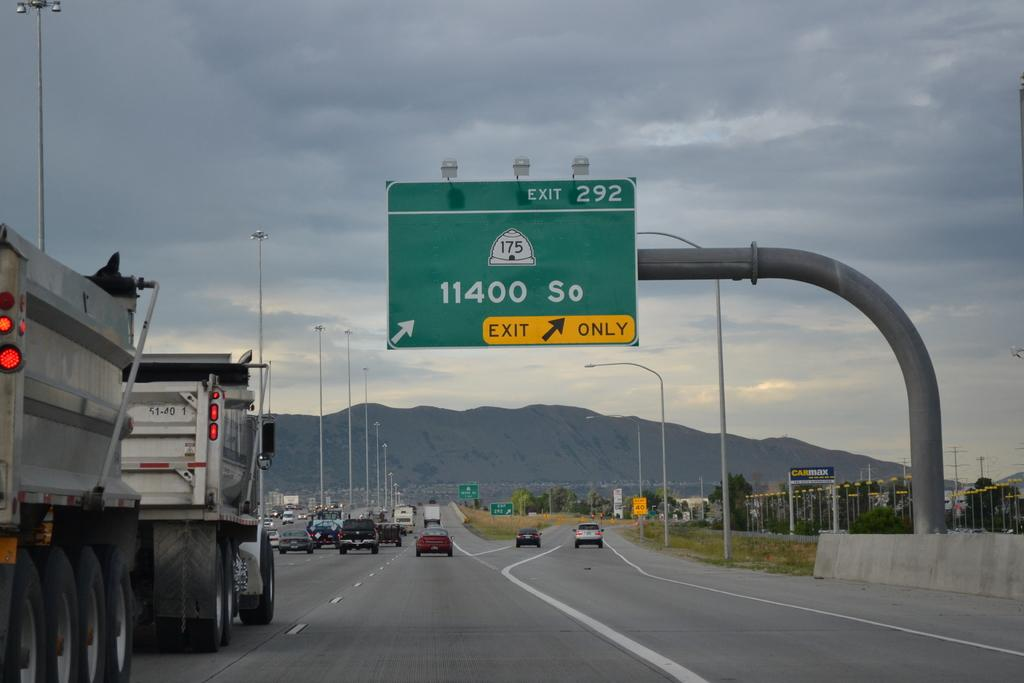<image>
Present a compact description of the photo's key features. The sign for exit 292 leads to 11400 South. 